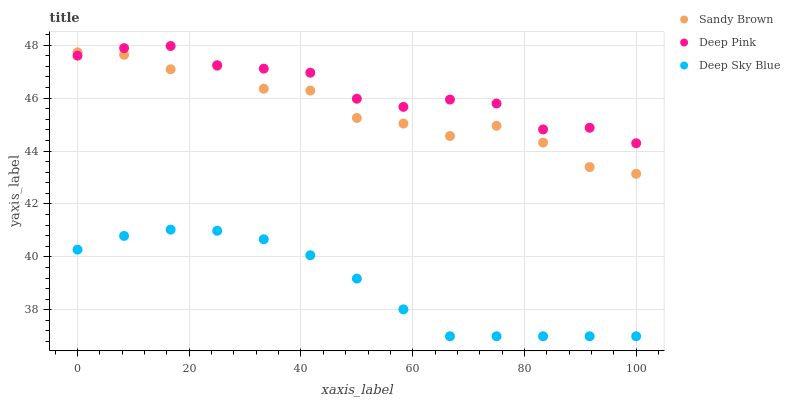Does Deep Sky Blue have the minimum area under the curve?
Answer yes or no. Yes. Does Deep Pink have the maximum area under the curve?
Answer yes or no. Yes. Does Sandy Brown have the minimum area under the curve?
Answer yes or no. No. Does Sandy Brown have the maximum area under the curve?
Answer yes or no. No. Is Deep Sky Blue the smoothest?
Answer yes or no. Yes. Is Sandy Brown the roughest?
Answer yes or no. Yes. Is Sandy Brown the smoothest?
Answer yes or no. No. Is Deep Sky Blue the roughest?
Answer yes or no. No. Does Deep Sky Blue have the lowest value?
Answer yes or no. Yes. Does Sandy Brown have the lowest value?
Answer yes or no. No. Does Deep Pink have the highest value?
Answer yes or no. Yes. Does Sandy Brown have the highest value?
Answer yes or no. No. Is Deep Sky Blue less than Sandy Brown?
Answer yes or no. Yes. Is Deep Pink greater than Deep Sky Blue?
Answer yes or no. Yes. Does Deep Pink intersect Sandy Brown?
Answer yes or no. Yes. Is Deep Pink less than Sandy Brown?
Answer yes or no. No. Is Deep Pink greater than Sandy Brown?
Answer yes or no. No. Does Deep Sky Blue intersect Sandy Brown?
Answer yes or no. No. 